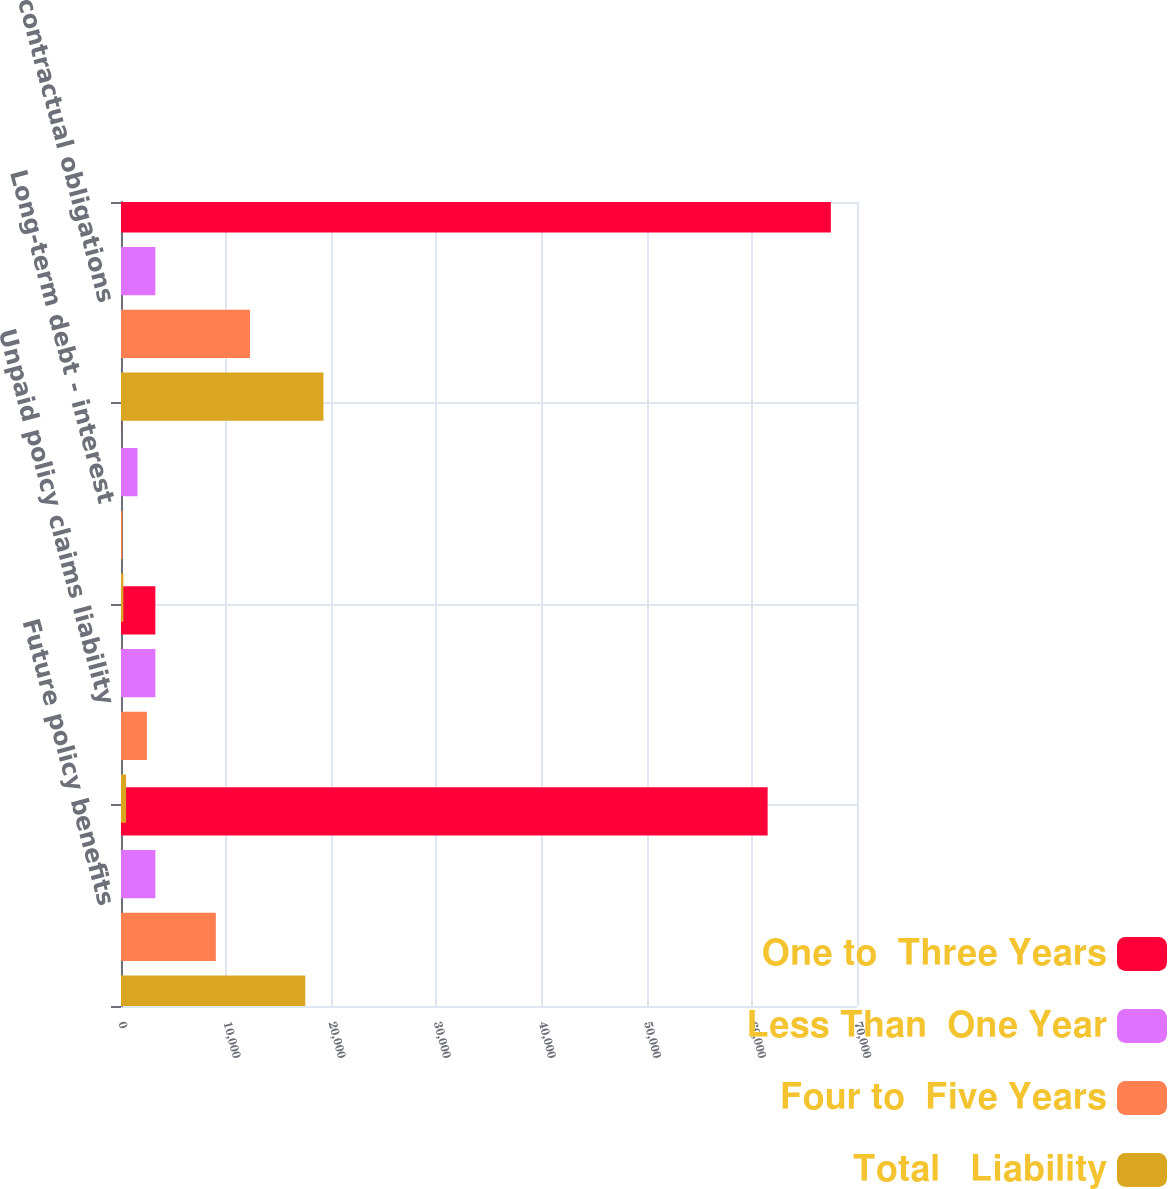Convert chart. <chart><loc_0><loc_0><loc_500><loc_500><stacked_bar_chart><ecel><fcel>Future policy benefits<fcel>Unpaid policy claims liability<fcel>Long-term debt - interest<fcel>Total contractual obligations<nl><fcel>One to  Three Years<fcel>61501<fcel>3270<fcel>16<fcel>67514<nl><fcel>Less Than  One Year<fcel>3270<fcel>3270<fcel>1572<fcel>3270<nl><fcel>Four to  Five Years<fcel>9018<fcel>2463<fcel>119<fcel>12268<nl><fcel>Total   Liability<fcel>17528<fcel>483<fcel>226<fcel>19254<nl></chart> 